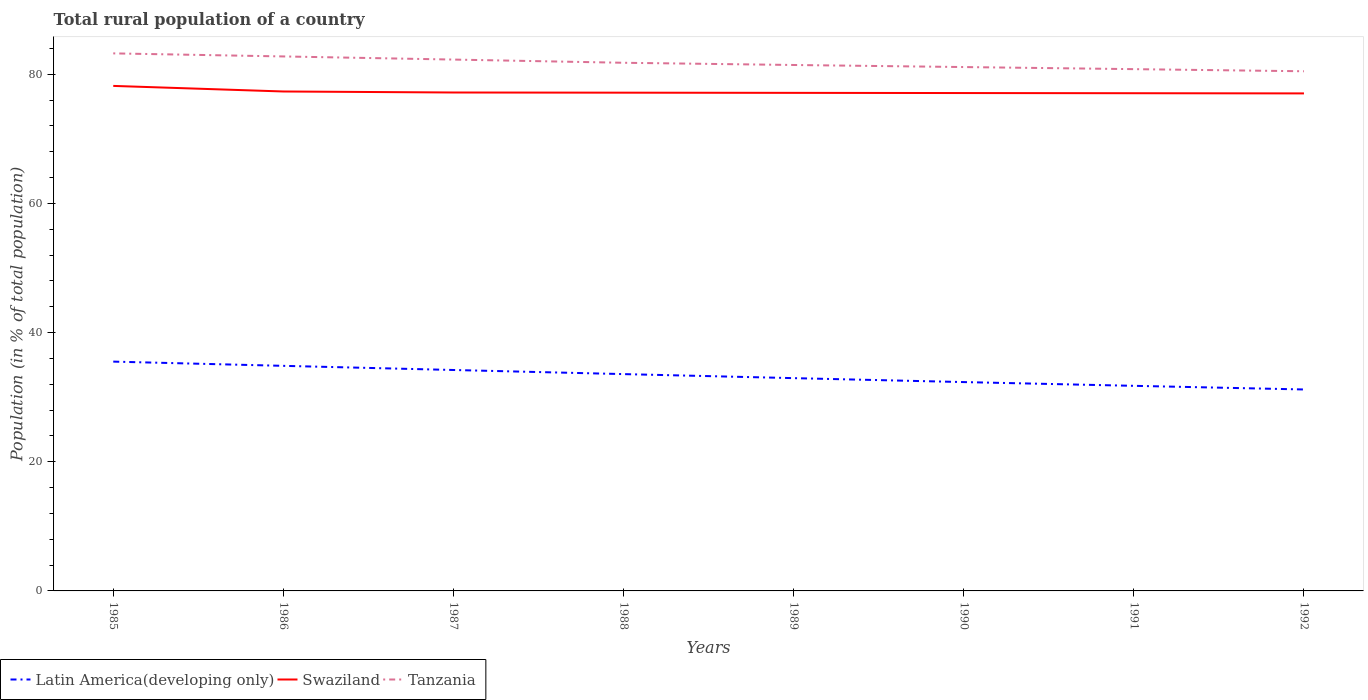Does the line corresponding to Tanzania intersect with the line corresponding to Swaziland?
Provide a succinct answer. No. Is the number of lines equal to the number of legend labels?
Your answer should be compact. Yes. Across all years, what is the maximum rural population in Tanzania?
Your answer should be very brief. 80.46. In which year was the rural population in Latin America(developing only) maximum?
Offer a terse response. 1992. What is the total rural population in Latin America(developing only) in the graph?
Give a very brief answer. 2.51. What is the difference between the highest and the second highest rural population in Tanzania?
Give a very brief answer. 2.77. What is the difference between the highest and the lowest rural population in Latin America(developing only)?
Offer a terse response. 4. How many lines are there?
Offer a very short reply. 3. Does the graph contain grids?
Make the answer very short. No. What is the title of the graph?
Offer a very short reply. Total rural population of a country. Does "Northern Mariana Islands" appear as one of the legend labels in the graph?
Make the answer very short. No. What is the label or title of the X-axis?
Provide a short and direct response. Years. What is the label or title of the Y-axis?
Your response must be concise. Population (in % of total population). What is the Population (in % of total population) in Latin America(developing only) in 1985?
Your response must be concise. 35.51. What is the Population (in % of total population) of Swaziland in 1985?
Provide a succinct answer. 78.2. What is the Population (in % of total population) of Tanzania in 1985?
Offer a terse response. 83.23. What is the Population (in % of total population) in Latin America(developing only) in 1986?
Offer a very short reply. 34.85. What is the Population (in % of total population) in Swaziland in 1986?
Make the answer very short. 77.33. What is the Population (in % of total population) in Tanzania in 1986?
Make the answer very short. 82.76. What is the Population (in % of total population) of Latin America(developing only) in 1987?
Make the answer very short. 34.21. What is the Population (in % of total population) in Swaziland in 1987?
Offer a terse response. 77.18. What is the Population (in % of total population) of Tanzania in 1987?
Ensure brevity in your answer.  82.28. What is the Population (in % of total population) in Latin America(developing only) in 1988?
Make the answer very short. 33.57. What is the Population (in % of total population) in Swaziland in 1988?
Provide a succinct answer. 77.15. What is the Population (in % of total population) in Tanzania in 1988?
Give a very brief answer. 81.78. What is the Population (in % of total population) of Latin America(developing only) in 1989?
Offer a terse response. 32.95. What is the Population (in % of total population) of Swaziland in 1989?
Your response must be concise. 77.12. What is the Population (in % of total population) of Tanzania in 1989?
Your response must be concise. 81.44. What is the Population (in % of total population) in Latin America(developing only) in 1990?
Your answer should be very brief. 32.34. What is the Population (in % of total population) in Swaziland in 1990?
Offer a very short reply. 77.09. What is the Population (in % of total population) in Tanzania in 1990?
Ensure brevity in your answer.  81.12. What is the Population (in % of total population) in Latin America(developing only) in 1991?
Offer a terse response. 31.76. What is the Population (in % of total population) in Swaziland in 1991?
Make the answer very short. 77.06. What is the Population (in % of total population) in Tanzania in 1991?
Ensure brevity in your answer.  80.79. What is the Population (in % of total population) in Latin America(developing only) in 1992?
Your response must be concise. 31.19. What is the Population (in % of total population) of Swaziland in 1992?
Give a very brief answer. 77.04. What is the Population (in % of total population) in Tanzania in 1992?
Ensure brevity in your answer.  80.46. Across all years, what is the maximum Population (in % of total population) of Latin America(developing only)?
Make the answer very short. 35.51. Across all years, what is the maximum Population (in % of total population) in Swaziland?
Provide a succinct answer. 78.2. Across all years, what is the maximum Population (in % of total population) in Tanzania?
Make the answer very short. 83.23. Across all years, what is the minimum Population (in % of total population) of Latin America(developing only)?
Ensure brevity in your answer.  31.19. Across all years, what is the minimum Population (in % of total population) in Swaziland?
Provide a succinct answer. 77.04. Across all years, what is the minimum Population (in % of total population) of Tanzania?
Make the answer very short. 80.46. What is the total Population (in % of total population) of Latin America(developing only) in the graph?
Provide a succinct answer. 266.37. What is the total Population (in % of total population) in Swaziland in the graph?
Your answer should be compact. 618.16. What is the total Population (in % of total population) in Tanzania in the graph?
Make the answer very short. 653.85. What is the difference between the Population (in % of total population) of Latin America(developing only) in 1985 and that in 1986?
Provide a succinct answer. 0.65. What is the difference between the Population (in % of total population) in Swaziland in 1985 and that in 1986?
Your response must be concise. 0.86. What is the difference between the Population (in % of total population) in Tanzania in 1985 and that in 1986?
Your answer should be very brief. 0.47. What is the difference between the Population (in % of total population) of Latin America(developing only) in 1985 and that in 1987?
Make the answer very short. 1.3. What is the difference between the Population (in % of total population) in Swaziland in 1985 and that in 1987?
Give a very brief answer. 1.02. What is the difference between the Population (in % of total population) of Tanzania in 1985 and that in 1987?
Keep it short and to the point. 0.96. What is the difference between the Population (in % of total population) in Latin America(developing only) in 1985 and that in 1988?
Ensure brevity in your answer.  1.93. What is the difference between the Population (in % of total population) of Swaziland in 1985 and that in 1988?
Make the answer very short. 1.05. What is the difference between the Population (in % of total population) of Tanzania in 1985 and that in 1988?
Offer a terse response. 1.45. What is the difference between the Population (in % of total population) of Latin America(developing only) in 1985 and that in 1989?
Ensure brevity in your answer.  2.56. What is the difference between the Population (in % of total population) of Swaziland in 1985 and that in 1989?
Your answer should be compact. 1.08. What is the difference between the Population (in % of total population) of Tanzania in 1985 and that in 1989?
Offer a terse response. 1.8. What is the difference between the Population (in % of total population) in Latin America(developing only) in 1985 and that in 1990?
Ensure brevity in your answer.  3.17. What is the difference between the Population (in % of total population) in Swaziland in 1985 and that in 1990?
Provide a succinct answer. 1.1. What is the difference between the Population (in % of total population) of Tanzania in 1985 and that in 1990?
Your answer should be compact. 2.12. What is the difference between the Population (in % of total population) in Latin America(developing only) in 1985 and that in 1991?
Your response must be concise. 3.75. What is the difference between the Population (in % of total population) of Swaziland in 1985 and that in 1991?
Offer a terse response. 1.13. What is the difference between the Population (in % of total population) of Tanzania in 1985 and that in 1991?
Offer a very short reply. 2.44. What is the difference between the Population (in % of total population) in Latin America(developing only) in 1985 and that in 1992?
Provide a short and direct response. 4.31. What is the difference between the Population (in % of total population) in Swaziland in 1985 and that in 1992?
Provide a short and direct response. 1.16. What is the difference between the Population (in % of total population) in Tanzania in 1985 and that in 1992?
Your response must be concise. 2.77. What is the difference between the Population (in % of total population) of Latin America(developing only) in 1986 and that in 1987?
Your answer should be compact. 0.64. What is the difference between the Population (in % of total population) in Swaziland in 1986 and that in 1987?
Your answer should be very brief. 0.16. What is the difference between the Population (in % of total population) of Tanzania in 1986 and that in 1987?
Ensure brevity in your answer.  0.48. What is the difference between the Population (in % of total population) of Latin America(developing only) in 1986 and that in 1988?
Make the answer very short. 1.28. What is the difference between the Population (in % of total population) of Swaziland in 1986 and that in 1988?
Your response must be concise. 0.18. What is the difference between the Population (in % of total population) of Tanzania in 1986 and that in 1988?
Give a very brief answer. 0.98. What is the difference between the Population (in % of total population) of Latin America(developing only) in 1986 and that in 1989?
Provide a succinct answer. 1.9. What is the difference between the Population (in % of total population) in Swaziland in 1986 and that in 1989?
Give a very brief answer. 0.21. What is the difference between the Population (in % of total population) of Tanzania in 1986 and that in 1989?
Keep it short and to the point. 1.32. What is the difference between the Population (in % of total population) of Latin America(developing only) in 1986 and that in 1990?
Your answer should be compact. 2.51. What is the difference between the Population (in % of total population) of Swaziland in 1986 and that in 1990?
Your answer should be compact. 0.24. What is the difference between the Population (in % of total population) of Tanzania in 1986 and that in 1990?
Provide a succinct answer. 1.64. What is the difference between the Population (in % of total population) of Latin America(developing only) in 1986 and that in 1991?
Make the answer very short. 3.1. What is the difference between the Population (in % of total population) of Swaziland in 1986 and that in 1991?
Provide a succinct answer. 0.27. What is the difference between the Population (in % of total population) of Tanzania in 1986 and that in 1991?
Offer a terse response. 1.97. What is the difference between the Population (in % of total population) in Latin America(developing only) in 1986 and that in 1992?
Your answer should be compact. 3.66. What is the difference between the Population (in % of total population) of Swaziland in 1986 and that in 1992?
Your response must be concise. 0.3. What is the difference between the Population (in % of total population) in Tanzania in 1986 and that in 1992?
Provide a short and direct response. 2.29. What is the difference between the Population (in % of total population) of Latin America(developing only) in 1987 and that in 1988?
Your response must be concise. 0.64. What is the difference between the Population (in % of total population) in Swaziland in 1987 and that in 1988?
Ensure brevity in your answer.  0.03. What is the difference between the Population (in % of total population) in Tanzania in 1987 and that in 1988?
Your answer should be very brief. 0.5. What is the difference between the Population (in % of total population) of Latin America(developing only) in 1987 and that in 1989?
Ensure brevity in your answer.  1.26. What is the difference between the Population (in % of total population) of Swaziland in 1987 and that in 1989?
Provide a short and direct response. 0.06. What is the difference between the Population (in % of total population) of Tanzania in 1987 and that in 1989?
Keep it short and to the point. 0.84. What is the difference between the Population (in % of total population) of Latin America(developing only) in 1987 and that in 1990?
Make the answer very short. 1.87. What is the difference between the Population (in % of total population) in Swaziland in 1987 and that in 1990?
Your answer should be very brief. 0.08. What is the difference between the Population (in % of total population) in Tanzania in 1987 and that in 1990?
Give a very brief answer. 1.16. What is the difference between the Population (in % of total population) of Latin America(developing only) in 1987 and that in 1991?
Offer a terse response. 2.45. What is the difference between the Population (in % of total population) of Swaziland in 1987 and that in 1991?
Offer a terse response. 0.11. What is the difference between the Population (in % of total population) of Tanzania in 1987 and that in 1991?
Ensure brevity in your answer.  1.48. What is the difference between the Population (in % of total population) in Latin America(developing only) in 1987 and that in 1992?
Your response must be concise. 3.02. What is the difference between the Population (in % of total population) in Swaziland in 1987 and that in 1992?
Provide a succinct answer. 0.14. What is the difference between the Population (in % of total population) in Tanzania in 1987 and that in 1992?
Make the answer very short. 1.81. What is the difference between the Population (in % of total population) in Latin America(developing only) in 1988 and that in 1989?
Keep it short and to the point. 0.62. What is the difference between the Population (in % of total population) of Swaziland in 1988 and that in 1989?
Offer a terse response. 0.03. What is the difference between the Population (in % of total population) in Tanzania in 1988 and that in 1989?
Provide a succinct answer. 0.34. What is the difference between the Population (in % of total population) in Latin America(developing only) in 1988 and that in 1990?
Offer a terse response. 1.23. What is the difference between the Population (in % of total population) in Swaziland in 1988 and that in 1990?
Give a very brief answer. 0.06. What is the difference between the Population (in % of total population) of Tanzania in 1988 and that in 1990?
Provide a short and direct response. 0.66. What is the difference between the Population (in % of total population) of Latin America(developing only) in 1988 and that in 1991?
Give a very brief answer. 1.82. What is the difference between the Population (in % of total population) in Swaziland in 1988 and that in 1991?
Offer a very short reply. 0.08. What is the difference between the Population (in % of total population) of Latin America(developing only) in 1988 and that in 1992?
Ensure brevity in your answer.  2.38. What is the difference between the Population (in % of total population) of Swaziland in 1988 and that in 1992?
Your response must be concise. 0.11. What is the difference between the Population (in % of total population) of Tanzania in 1988 and that in 1992?
Provide a succinct answer. 1.31. What is the difference between the Population (in % of total population) of Latin America(developing only) in 1989 and that in 1990?
Your answer should be compact. 0.61. What is the difference between the Population (in % of total population) of Swaziland in 1989 and that in 1990?
Provide a succinct answer. 0.03. What is the difference between the Population (in % of total population) of Tanzania in 1989 and that in 1990?
Ensure brevity in your answer.  0.32. What is the difference between the Population (in % of total population) in Latin America(developing only) in 1989 and that in 1991?
Offer a terse response. 1.19. What is the difference between the Population (in % of total population) in Swaziland in 1989 and that in 1991?
Your response must be concise. 0.06. What is the difference between the Population (in % of total population) in Tanzania in 1989 and that in 1991?
Keep it short and to the point. 0.64. What is the difference between the Population (in % of total population) of Latin America(developing only) in 1989 and that in 1992?
Offer a terse response. 1.76. What is the difference between the Population (in % of total population) of Swaziland in 1989 and that in 1992?
Your answer should be compact. 0.08. What is the difference between the Population (in % of total population) in Tanzania in 1989 and that in 1992?
Your answer should be compact. 0.97. What is the difference between the Population (in % of total population) in Latin America(developing only) in 1990 and that in 1991?
Ensure brevity in your answer.  0.58. What is the difference between the Population (in % of total population) of Swaziland in 1990 and that in 1991?
Provide a succinct answer. 0.03. What is the difference between the Population (in % of total population) in Tanzania in 1990 and that in 1991?
Provide a succinct answer. 0.32. What is the difference between the Population (in % of total population) of Latin America(developing only) in 1990 and that in 1992?
Your answer should be compact. 1.15. What is the difference between the Population (in % of total population) of Swaziland in 1990 and that in 1992?
Your answer should be compact. 0.06. What is the difference between the Population (in % of total population) in Tanzania in 1990 and that in 1992?
Give a very brief answer. 0.65. What is the difference between the Population (in % of total population) of Latin America(developing only) in 1991 and that in 1992?
Offer a terse response. 0.56. What is the difference between the Population (in % of total population) in Swaziland in 1991 and that in 1992?
Ensure brevity in your answer.  0.03. What is the difference between the Population (in % of total population) in Tanzania in 1991 and that in 1992?
Your answer should be compact. 0.33. What is the difference between the Population (in % of total population) of Latin America(developing only) in 1985 and the Population (in % of total population) of Swaziland in 1986?
Offer a very short reply. -41.83. What is the difference between the Population (in % of total population) of Latin America(developing only) in 1985 and the Population (in % of total population) of Tanzania in 1986?
Your answer should be compact. -47.25. What is the difference between the Population (in % of total population) in Swaziland in 1985 and the Population (in % of total population) in Tanzania in 1986?
Keep it short and to the point. -4.56. What is the difference between the Population (in % of total population) in Latin America(developing only) in 1985 and the Population (in % of total population) in Swaziland in 1987?
Your answer should be very brief. -41.67. What is the difference between the Population (in % of total population) of Latin America(developing only) in 1985 and the Population (in % of total population) of Tanzania in 1987?
Give a very brief answer. -46.77. What is the difference between the Population (in % of total population) of Swaziland in 1985 and the Population (in % of total population) of Tanzania in 1987?
Ensure brevity in your answer.  -4.08. What is the difference between the Population (in % of total population) of Latin America(developing only) in 1985 and the Population (in % of total population) of Swaziland in 1988?
Offer a terse response. -41.64. What is the difference between the Population (in % of total population) of Latin America(developing only) in 1985 and the Population (in % of total population) of Tanzania in 1988?
Ensure brevity in your answer.  -46.27. What is the difference between the Population (in % of total population) in Swaziland in 1985 and the Population (in % of total population) in Tanzania in 1988?
Give a very brief answer. -3.58. What is the difference between the Population (in % of total population) in Latin America(developing only) in 1985 and the Population (in % of total population) in Swaziland in 1989?
Provide a succinct answer. -41.61. What is the difference between the Population (in % of total population) of Latin America(developing only) in 1985 and the Population (in % of total population) of Tanzania in 1989?
Provide a succinct answer. -45.93. What is the difference between the Population (in % of total population) in Swaziland in 1985 and the Population (in % of total population) in Tanzania in 1989?
Offer a terse response. -3.24. What is the difference between the Population (in % of total population) in Latin America(developing only) in 1985 and the Population (in % of total population) in Swaziland in 1990?
Offer a terse response. -41.59. What is the difference between the Population (in % of total population) in Latin America(developing only) in 1985 and the Population (in % of total population) in Tanzania in 1990?
Your answer should be very brief. -45.61. What is the difference between the Population (in % of total population) in Swaziland in 1985 and the Population (in % of total population) in Tanzania in 1990?
Provide a succinct answer. -2.92. What is the difference between the Population (in % of total population) in Latin America(developing only) in 1985 and the Population (in % of total population) in Swaziland in 1991?
Offer a very short reply. -41.56. What is the difference between the Population (in % of total population) in Latin America(developing only) in 1985 and the Population (in % of total population) in Tanzania in 1991?
Your answer should be compact. -45.29. What is the difference between the Population (in % of total population) of Swaziland in 1985 and the Population (in % of total population) of Tanzania in 1991?
Give a very brief answer. -2.6. What is the difference between the Population (in % of total population) in Latin America(developing only) in 1985 and the Population (in % of total population) in Swaziland in 1992?
Your answer should be compact. -41.53. What is the difference between the Population (in % of total population) in Latin America(developing only) in 1985 and the Population (in % of total population) in Tanzania in 1992?
Provide a short and direct response. -44.96. What is the difference between the Population (in % of total population) in Swaziland in 1985 and the Population (in % of total population) in Tanzania in 1992?
Your answer should be compact. -2.27. What is the difference between the Population (in % of total population) of Latin America(developing only) in 1986 and the Population (in % of total population) of Swaziland in 1987?
Your answer should be compact. -42.32. What is the difference between the Population (in % of total population) of Latin America(developing only) in 1986 and the Population (in % of total population) of Tanzania in 1987?
Your answer should be compact. -47.42. What is the difference between the Population (in % of total population) of Swaziland in 1986 and the Population (in % of total population) of Tanzania in 1987?
Offer a terse response. -4.94. What is the difference between the Population (in % of total population) in Latin America(developing only) in 1986 and the Population (in % of total population) in Swaziland in 1988?
Provide a succinct answer. -42.3. What is the difference between the Population (in % of total population) in Latin America(developing only) in 1986 and the Population (in % of total population) in Tanzania in 1988?
Make the answer very short. -46.93. What is the difference between the Population (in % of total population) of Swaziland in 1986 and the Population (in % of total population) of Tanzania in 1988?
Your response must be concise. -4.45. What is the difference between the Population (in % of total population) in Latin America(developing only) in 1986 and the Population (in % of total population) in Swaziland in 1989?
Your answer should be compact. -42.27. What is the difference between the Population (in % of total population) in Latin America(developing only) in 1986 and the Population (in % of total population) in Tanzania in 1989?
Keep it short and to the point. -46.58. What is the difference between the Population (in % of total population) in Swaziland in 1986 and the Population (in % of total population) in Tanzania in 1989?
Your answer should be very brief. -4.1. What is the difference between the Population (in % of total population) in Latin America(developing only) in 1986 and the Population (in % of total population) in Swaziland in 1990?
Your answer should be compact. -42.24. What is the difference between the Population (in % of total population) of Latin America(developing only) in 1986 and the Population (in % of total population) of Tanzania in 1990?
Your answer should be very brief. -46.26. What is the difference between the Population (in % of total population) in Swaziland in 1986 and the Population (in % of total population) in Tanzania in 1990?
Offer a very short reply. -3.78. What is the difference between the Population (in % of total population) in Latin America(developing only) in 1986 and the Population (in % of total population) in Swaziland in 1991?
Your answer should be very brief. -42.21. What is the difference between the Population (in % of total population) in Latin America(developing only) in 1986 and the Population (in % of total population) in Tanzania in 1991?
Offer a very short reply. -45.94. What is the difference between the Population (in % of total population) in Swaziland in 1986 and the Population (in % of total population) in Tanzania in 1991?
Your answer should be compact. -3.46. What is the difference between the Population (in % of total population) of Latin America(developing only) in 1986 and the Population (in % of total population) of Swaziland in 1992?
Your answer should be compact. -42.18. What is the difference between the Population (in % of total population) in Latin America(developing only) in 1986 and the Population (in % of total population) in Tanzania in 1992?
Provide a succinct answer. -45.61. What is the difference between the Population (in % of total population) in Swaziland in 1986 and the Population (in % of total population) in Tanzania in 1992?
Your response must be concise. -3.13. What is the difference between the Population (in % of total population) in Latin America(developing only) in 1987 and the Population (in % of total population) in Swaziland in 1988?
Ensure brevity in your answer.  -42.94. What is the difference between the Population (in % of total population) in Latin America(developing only) in 1987 and the Population (in % of total population) in Tanzania in 1988?
Make the answer very short. -47.57. What is the difference between the Population (in % of total population) in Swaziland in 1987 and the Population (in % of total population) in Tanzania in 1988?
Ensure brevity in your answer.  -4.6. What is the difference between the Population (in % of total population) of Latin America(developing only) in 1987 and the Population (in % of total population) of Swaziland in 1989?
Your answer should be very brief. -42.91. What is the difference between the Population (in % of total population) of Latin America(developing only) in 1987 and the Population (in % of total population) of Tanzania in 1989?
Offer a very short reply. -47.23. What is the difference between the Population (in % of total population) in Swaziland in 1987 and the Population (in % of total population) in Tanzania in 1989?
Provide a succinct answer. -4.26. What is the difference between the Population (in % of total population) in Latin America(developing only) in 1987 and the Population (in % of total population) in Swaziland in 1990?
Your answer should be compact. -42.88. What is the difference between the Population (in % of total population) in Latin America(developing only) in 1987 and the Population (in % of total population) in Tanzania in 1990?
Provide a succinct answer. -46.91. What is the difference between the Population (in % of total population) in Swaziland in 1987 and the Population (in % of total population) in Tanzania in 1990?
Keep it short and to the point. -3.94. What is the difference between the Population (in % of total population) of Latin America(developing only) in 1987 and the Population (in % of total population) of Swaziland in 1991?
Provide a succinct answer. -42.86. What is the difference between the Population (in % of total population) of Latin America(developing only) in 1987 and the Population (in % of total population) of Tanzania in 1991?
Offer a very short reply. -46.58. What is the difference between the Population (in % of total population) in Swaziland in 1987 and the Population (in % of total population) in Tanzania in 1991?
Ensure brevity in your answer.  -3.62. What is the difference between the Population (in % of total population) in Latin America(developing only) in 1987 and the Population (in % of total population) in Swaziland in 1992?
Provide a short and direct response. -42.83. What is the difference between the Population (in % of total population) of Latin America(developing only) in 1987 and the Population (in % of total population) of Tanzania in 1992?
Your answer should be very brief. -46.26. What is the difference between the Population (in % of total population) in Swaziland in 1987 and the Population (in % of total population) in Tanzania in 1992?
Your response must be concise. -3.29. What is the difference between the Population (in % of total population) in Latin America(developing only) in 1988 and the Population (in % of total population) in Swaziland in 1989?
Keep it short and to the point. -43.55. What is the difference between the Population (in % of total population) in Latin America(developing only) in 1988 and the Population (in % of total population) in Tanzania in 1989?
Make the answer very short. -47.86. What is the difference between the Population (in % of total population) of Swaziland in 1988 and the Population (in % of total population) of Tanzania in 1989?
Give a very brief answer. -4.29. What is the difference between the Population (in % of total population) of Latin America(developing only) in 1988 and the Population (in % of total population) of Swaziland in 1990?
Make the answer very short. -43.52. What is the difference between the Population (in % of total population) of Latin America(developing only) in 1988 and the Population (in % of total population) of Tanzania in 1990?
Ensure brevity in your answer.  -47.54. What is the difference between the Population (in % of total population) in Swaziland in 1988 and the Population (in % of total population) in Tanzania in 1990?
Ensure brevity in your answer.  -3.97. What is the difference between the Population (in % of total population) in Latin America(developing only) in 1988 and the Population (in % of total population) in Swaziland in 1991?
Offer a terse response. -43.49. What is the difference between the Population (in % of total population) of Latin America(developing only) in 1988 and the Population (in % of total population) of Tanzania in 1991?
Give a very brief answer. -47.22. What is the difference between the Population (in % of total population) of Swaziland in 1988 and the Population (in % of total population) of Tanzania in 1991?
Provide a succinct answer. -3.64. What is the difference between the Population (in % of total population) of Latin America(developing only) in 1988 and the Population (in % of total population) of Swaziland in 1992?
Make the answer very short. -43.46. What is the difference between the Population (in % of total population) in Latin America(developing only) in 1988 and the Population (in % of total population) in Tanzania in 1992?
Make the answer very short. -46.89. What is the difference between the Population (in % of total population) in Swaziland in 1988 and the Population (in % of total population) in Tanzania in 1992?
Ensure brevity in your answer.  -3.32. What is the difference between the Population (in % of total population) of Latin America(developing only) in 1989 and the Population (in % of total population) of Swaziland in 1990?
Give a very brief answer. -44.14. What is the difference between the Population (in % of total population) in Latin America(developing only) in 1989 and the Population (in % of total population) in Tanzania in 1990?
Your answer should be very brief. -48.17. What is the difference between the Population (in % of total population) of Swaziland in 1989 and the Population (in % of total population) of Tanzania in 1990?
Offer a terse response. -4. What is the difference between the Population (in % of total population) of Latin America(developing only) in 1989 and the Population (in % of total population) of Swaziland in 1991?
Offer a very short reply. -44.12. What is the difference between the Population (in % of total population) of Latin America(developing only) in 1989 and the Population (in % of total population) of Tanzania in 1991?
Ensure brevity in your answer.  -47.84. What is the difference between the Population (in % of total population) in Swaziland in 1989 and the Population (in % of total population) in Tanzania in 1991?
Offer a terse response. -3.67. What is the difference between the Population (in % of total population) of Latin America(developing only) in 1989 and the Population (in % of total population) of Swaziland in 1992?
Provide a short and direct response. -44.09. What is the difference between the Population (in % of total population) of Latin America(developing only) in 1989 and the Population (in % of total population) of Tanzania in 1992?
Ensure brevity in your answer.  -47.52. What is the difference between the Population (in % of total population) of Swaziland in 1989 and the Population (in % of total population) of Tanzania in 1992?
Make the answer very short. -3.34. What is the difference between the Population (in % of total population) in Latin America(developing only) in 1990 and the Population (in % of total population) in Swaziland in 1991?
Your answer should be compact. -44.73. What is the difference between the Population (in % of total population) of Latin America(developing only) in 1990 and the Population (in % of total population) of Tanzania in 1991?
Provide a succinct answer. -48.45. What is the difference between the Population (in % of total population) in Latin America(developing only) in 1990 and the Population (in % of total population) in Swaziland in 1992?
Your response must be concise. -44.7. What is the difference between the Population (in % of total population) of Latin America(developing only) in 1990 and the Population (in % of total population) of Tanzania in 1992?
Make the answer very short. -48.13. What is the difference between the Population (in % of total population) in Swaziland in 1990 and the Population (in % of total population) in Tanzania in 1992?
Provide a short and direct response. -3.37. What is the difference between the Population (in % of total population) in Latin America(developing only) in 1991 and the Population (in % of total population) in Swaziland in 1992?
Provide a short and direct response. -45.28. What is the difference between the Population (in % of total population) in Latin America(developing only) in 1991 and the Population (in % of total population) in Tanzania in 1992?
Make the answer very short. -48.71. What is the difference between the Population (in % of total population) in Swaziland in 1991 and the Population (in % of total population) in Tanzania in 1992?
Offer a very short reply. -3.4. What is the average Population (in % of total population) of Latin America(developing only) per year?
Provide a succinct answer. 33.3. What is the average Population (in % of total population) of Swaziland per year?
Make the answer very short. 77.27. What is the average Population (in % of total population) of Tanzania per year?
Offer a terse response. 81.73. In the year 1985, what is the difference between the Population (in % of total population) of Latin America(developing only) and Population (in % of total population) of Swaziland?
Make the answer very short. -42.69. In the year 1985, what is the difference between the Population (in % of total population) of Latin America(developing only) and Population (in % of total population) of Tanzania?
Ensure brevity in your answer.  -47.73. In the year 1985, what is the difference between the Population (in % of total population) of Swaziland and Population (in % of total population) of Tanzania?
Make the answer very short. -5.04. In the year 1986, what is the difference between the Population (in % of total population) of Latin America(developing only) and Population (in % of total population) of Swaziland?
Give a very brief answer. -42.48. In the year 1986, what is the difference between the Population (in % of total population) in Latin America(developing only) and Population (in % of total population) in Tanzania?
Provide a succinct answer. -47.91. In the year 1986, what is the difference between the Population (in % of total population) of Swaziland and Population (in % of total population) of Tanzania?
Give a very brief answer. -5.43. In the year 1987, what is the difference between the Population (in % of total population) in Latin America(developing only) and Population (in % of total population) in Swaziland?
Your response must be concise. -42.97. In the year 1987, what is the difference between the Population (in % of total population) of Latin America(developing only) and Population (in % of total population) of Tanzania?
Offer a terse response. -48.07. In the year 1987, what is the difference between the Population (in % of total population) in Swaziland and Population (in % of total population) in Tanzania?
Your answer should be very brief. -5.1. In the year 1988, what is the difference between the Population (in % of total population) of Latin America(developing only) and Population (in % of total population) of Swaziland?
Offer a terse response. -43.58. In the year 1988, what is the difference between the Population (in % of total population) in Latin America(developing only) and Population (in % of total population) in Tanzania?
Keep it short and to the point. -48.21. In the year 1988, what is the difference between the Population (in % of total population) of Swaziland and Population (in % of total population) of Tanzania?
Offer a terse response. -4.63. In the year 1989, what is the difference between the Population (in % of total population) of Latin America(developing only) and Population (in % of total population) of Swaziland?
Make the answer very short. -44.17. In the year 1989, what is the difference between the Population (in % of total population) in Latin America(developing only) and Population (in % of total population) in Tanzania?
Your response must be concise. -48.49. In the year 1989, what is the difference between the Population (in % of total population) in Swaziland and Population (in % of total population) in Tanzania?
Offer a very short reply. -4.32. In the year 1990, what is the difference between the Population (in % of total population) in Latin America(developing only) and Population (in % of total population) in Swaziland?
Ensure brevity in your answer.  -44.75. In the year 1990, what is the difference between the Population (in % of total population) of Latin America(developing only) and Population (in % of total population) of Tanzania?
Provide a short and direct response. -48.78. In the year 1990, what is the difference between the Population (in % of total population) in Swaziland and Population (in % of total population) in Tanzania?
Give a very brief answer. -4.02. In the year 1991, what is the difference between the Population (in % of total population) of Latin America(developing only) and Population (in % of total population) of Swaziland?
Ensure brevity in your answer.  -45.31. In the year 1991, what is the difference between the Population (in % of total population) in Latin America(developing only) and Population (in % of total population) in Tanzania?
Provide a short and direct response. -49.04. In the year 1991, what is the difference between the Population (in % of total population) of Swaziland and Population (in % of total population) of Tanzania?
Your response must be concise. -3.73. In the year 1992, what is the difference between the Population (in % of total population) of Latin America(developing only) and Population (in % of total population) of Swaziland?
Your answer should be compact. -45.84. In the year 1992, what is the difference between the Population (in % of total population) of Latin America(developing only) and Population (in % of total population) of Tanzania?
Make the answer very short. -49.27. In the year 1992, what is the difference between the Population (in % of total population) in Swaziland and Population (in % of total population) in Tanzania?
Make the answer very short. -3.43. What is the ratio of the Population (in % of total population) in Latin America(developing only) in 1985 to that in 1986?
Offer a terse response. 1.02. What is the ratio of the Population (in % of total population) in Swaziland in 1985 to that in 1986?
Keep it short and to the point. 1.01. What is the ratio of the Population (in % of total population) in Latin America(developing only) in 1985 to that in 1987?
Your answer should be compact. 1.04. What is the ratio of the Population (in % of total population) in Swaziland in 1985 to that in 1987?
Give a very brief answer. 1.01. What is the ratio of the Population (in % of total population) of Tanzania in 1985 to that in 1987?
Your answer should be compact. 1.01. What is the ratio of the Population (in % of total population) in Latin America(developing only) in 1985 to that in 1988?
Keep it short and to the point. 1.06. What is the ratio of the Population (in % of total population) of Swaziland in 1985 to that in 1988?
Your answer should be compact. 1.01. What is the ratio of the Population (in % of total population) in Tanzania in 1985 to that in 1988?
Keep it short and to the point. 1.02. What is the ratio of the Population (in % of total population) of Latin America(developing only) in 1985 to that in 1989?
Offer a terse response. 1.08. What is the ratio of the Population (in % of total population) of Swaziland in 1985 to that in 1989?
Ensure brevity in your answer.  1.01. What is the ratio of the Population (in % of total population) in Tanzania in 1985 to that in 1989?
Keep it short and to the point. 1.02. What is the ratio of the Population (in % of total population) of Latin America(developing only) in 1985 to that in 1990?
Ensure brevity in your answer.  1.1. What is the ratio of the Population (in % of total population) in Swaziland in 1985 to that in 1990?
Your response must be concise. 1.01. What is the ratio of the Population (in % of total population) of Tanzania in 1985 to that in 1990?
Your response must be concise. 1.03. What is the ratio of the Population (in % of total population) in Latin America(developing only) in 1985 to that in 1991?
Ensure brevity in your answer.  1.12. What is the ratio of the Population (in % of total population) in Swaziland in 1985 to that in 1991?
Offer a very short reply. 1.01. What is the ratio of the Population (in % of total population) of Tanzania in 1985 to that in 1991?
Ensure brevity in your answer.  1.03. What is the ratio of the Population (in % of total population) in Latin America(developing only) in 1985 to that in 1992?
Your response must be concise. 1.14. What is the ratio of the Population (in % of total population) of Swaziland in 1985 to that in 1992?
Keep it short and to the point. 1.02. What is the ratio of the Population (in % of total population) of Tanzania in 1985 to that in 1992?
Your response must be concise. 1.03. What is the ratio of the Population (in % of total population) in Latin America(developing only) in 1986 to that in 1987?
Your answer should be very brief. 1.02. What is the ratio of the Population (in % of total population) in Tanzania in 1986 to that in 1987?
Give a very brief answer. 1.01. What is the ratio of the Population (in % of total population) of Latin America(developing only) in 1986 to that in 1988?
Your answer should be compact. 1.04. What is the ratio of the Population (in % of total population) of Swaziland in 1986 to that in 1988?
Offer a very short reply. 1. What is the ratio of the Population (in % of total population) of Latin America(developing only) in 1986 to that in 1989?
Your response must be concise. 1.06. What is the ratio of the Population (in % of total population) in Swaziland in 1986 to that in 1989?
Provide a succinct answer. 1. What is the ratio of the Population (in % of total population) of Tanzania in 1986 to that in 1989?
Keep it short and to the point. 1.02. What is the ratio of the Population (in % of total population) in Latin America(developing only) in 1986 to that in 1990?
Provide a succinct answer. 1.08. What is the ratio of the Population (in % of total population) in Swaziland in 1986 to that in 1990?
Keep it short and to the point. 1. What is the ratio of the Population (in % of total population) of Tanzania in 1986 to that in 1990?
Offer a very short reply. 1.02. What is the ratio of the Population (in % of total population) in Latin America(developing only) in 1986 to that in 1991?
Your answer should be compact. 1.1. What is the ratio of the Population (in % of total population) of Tanzania in 1986 to that in 1991?
Provide a succinct answer. 1.02. What is the ratio of the Population (in % of total population) of Latin America(developing only) in 1986 to that in 1992?
Your response must be concise. 1.12. What is the ratio of the Population (in % of total population) in Swaziland in 1986 to that in 1992?
Keep it short and to the point. 1. What is the ratio of the Population (in % of total population) in Tanzania in 1986 to that in 1992?
Your response must be concise. 1.03. What is the ratio of the Population (in % of total population) in Latin America(developing only) in 1987 to that in 1988?
Make the answer very short. 1.02. What is the ratio of the Population (in % of total population) in Latin America(developing only) in 1987 to that in 1989?
Provide a short and direct response. 1.04. What is the ratio of the Population (in % of total population) of Swaziland in 1987 to that in 1989?
Keep it short and to the point. 1. What is the ratio of the Population (in % of total population) in Tanzania in 1987 to that in 1989?
Provide a succinct answer. 1.01. What is the ratio of the Population (in % of total population) of Latin America(developing only) in 1987 to that in 1990?
Provide a short and direct response. 1.06. What is the ratio of the Population (in % of total population) of Swaziland in 1987 to that in 1990?
Your answer should be compact. 1. What is the ratio of the Population (in % of total population) in Tanzania in 1987 to that in 1990?
Keep it short and to the point. 1.01. What is the ratio of the Population (in % of total population) in Latin America(developing only) in 1987 to that in 1991?
Offer a terse response. 1.08. What is the ratio of the Population (in % of total population) in Tanzania in 1987 to that in 1991?
Provide a short and direct response. 1.02. What is the ratio of the Population (in % of total population) of Latin America(developing only) in 1987 to that in 1992?
Keep it short and to the point. 1.1. What is the ratio of the Population (in % of total population) of Swaziland in 1987 to that in 1992?
Your answer should be very brief. 1. What is the ratio of the Population (in % of total population) of Tanzania in 1987 to that in 1992?
Offer a very short reply. 1.02. What is the ratio of the Population (in % of total population) in Latin America(developing only) in 1988 to that in 1990?
Make the answer very short. 1.04. What is the ratio of the Population (in % of total population) of Swaziland in 1988 to that in 1990?
Offer a terse response. 1. What is the ratio of the Population (in % of total population) of Tanzania in 1988 to that in 1990?
Your answer should be compact. 1.01. What is the ratio of the Population (in % of total population) in Latin America(developing only) in 1988 to that in 1991?
Give a very brief answer. 1.06. What is the ratio of the Population (in % of total population) of Tanzania in 1988 to that in 1991?
Offer a very short reply. 1.01. What is the ratio of the Population (in % of total population) of Latin America(developing only) in 1988 to that in 1992?
Offer a very short reply. 1.08. What is the ratio of the Population (in % of total population) in Tanzania in 1988 to that in 1992?
Your answer should be very brief. 1.02. What is the ratio of the Population (in % of total population) of Latin America(developing only) in 1989 to that in 1990?
Provide a short and direct response. 1.02. What is the ratio of the Population (in % of total population) in Swaziland in 1989 to that in 1990?
Provide a short and direct response. 1. What is the ratio of the Population (in % of total population) in Tanzania in 1989 to that in 1990?
Your answer should be compact. 1. What is the ratio of the Population (in % of total population) of Latin America(developing only) in 1989 to that in 1991?
Offer a terse response. 1.04. What is the ratio of the Population (in % of total population) of Swaziland in 1989 to that in 1991?
Your answer should be very brief. 1. What is the ratio of the Population (in % of total population) in Tanzania in 1989 to that in 1991?
Provide a short and direct response. 1.01. What is the ratio of the Population (in % of total population) in Latin America(developing only) in 1989 to that in 1992?
Offer a very short reply. 1.06. What is the ratio of the Population (in % of total population) in Swaziland in 1989 to that in 1992?
Offer a terse response. 1. What is the ratio of the Population (in % of total population) in Tanzania in 1989 to that in 1992?
Provide a succinct answer. 1.01. What is the ratio of the Population (in % of total population) of Latin America(developing only) in 1990 to that in 1991?
Ensure brevity in your answer.  1.02. What is the ratio of the Population (in % of total population) in Swaziland in 1990 to that in 1991?
Offer a very short reply. 1. What is the ratio of the Population (in % of total population) of Latin America(developing only) in 1990 to that in 1992?
Make the answer very short. 1.04. What is the ratio of the Population (in % of total population) in Latin America(developing only) in 1991 to that in 1992?
Offer a terse response. 1.02. What is the ratio of the Population (in % of total population) of Swaziland in 1991 to that in 1992?
Your response must be concise. 1. What is the ratio of the Population (in % of total population) of Tanzania in 1991 to that in 1992?
Your answer should be compact. 1. What is the difference between the highest and the second highest Population (in % of total population) of Latin America(developing only)?
Offer a very short reply. 0.65. What is the difference between the highest and the second highest Population (in % of total population) in Swaziland?
Offer a terse response. 0.86. What is the difference between the highest and the second highest Population (in % of total population) of Tanzania?
Keep it short and to the point. 0.47. What is the difference between the highest and the lowest Population (in % of total population) of Latin America(developing only)?
Your response must be concise. 4.31. What is the difference between the highest and the lowest Population (in % of total population) in Swaziland?
Offer a terse response. 1.16. What is the difference between the highest and the lowest Population (in % of total population) in Tanzania?
Keep it short and to the point. 2.77. 